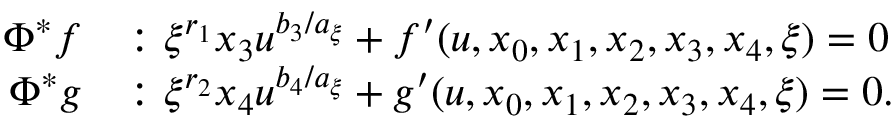<formula> <loc_0><loc_0><loc_500><loc_500>\begin{array} { r l } { \Phi ^ { * } f } & { \colon \xi ^ { r _ { 1 } } x _ { 3 } u ^ { b _ { 3 } / a _ { \xi } } + f ^ { \prime } ( u , x _ { 0 } , x _ { 1 } , x _ { 2 } , x _ { 3 } , x _ { 4 } , \xi ) = 0 } \\ { \Phi ^ { * } g } & { \colon \xi ^ { r _ { 2 } } x _ { 4 } u ^ { b _ { 4 } / a _ { \xi } } + g ^ { \prime } ( u , x _ { 0 } , x _ { 1 } , x _ { 2 } , x _ { 3 } , x _ { 4 } , \xi ) = 0 . } \end{array}</formula> 